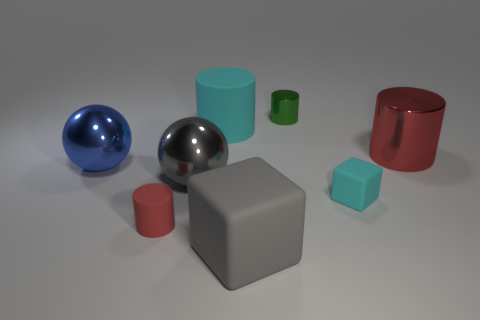Add 1 red matte cylinders. How many objects exist? 9 Subtract all green cylinders. How many cylinders are left? 3 Subtract all blue spheres. How many red cylinders are left? 2 Subtract all blocks. How many objects are left? 6 Subtract all cyan cylinders. How many cylinders are left? 3 Subtract 2 cylinders. How many cylinders are left? 2 Subtract all green cylinders. Subtract all blue spheres. How many cylinders are left? 3 Subtract all rubber cylinders. Subtract all large things. How many objects are left? 1 Add 5 large cylinders. How many large cylinders are left? 7 Add 3 gray balls. How many gray balls exist? 4 